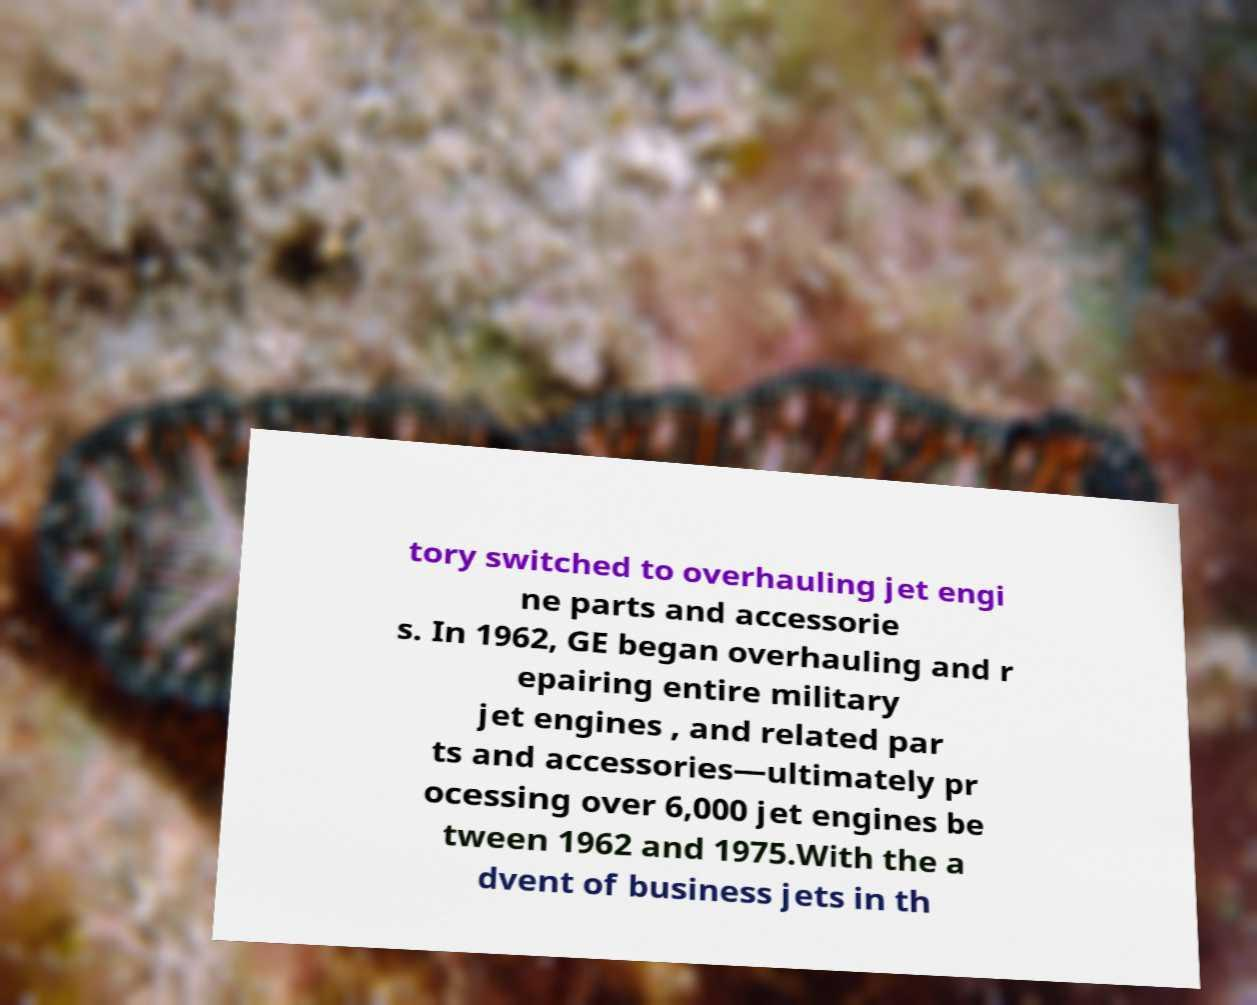There's text embedded in this image that I need extracted. Can you transcribe it verbatim? tory switched to overhauling jet engi ne parts and accessorie s. In 1962, GE began overhauling and r epairing entire military jet engines , and related par ts and accessories—ultimately pr ocessing over 6,000 jet engines be tween 1962 and 1975.With the a dvent of business jets in th 